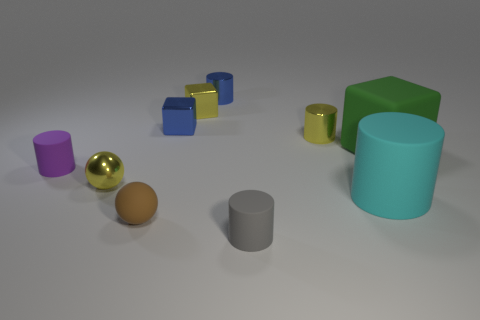Subtract all gray cylinders. How many cylinders are left? 4 Subtract all tiny blue cylinders. How many cylinders are left? 4 Subtract all red cylinders. Subtract all gray spheres. How many cylinders are left? 5 Subtract all balls. How many objects are left? 8 Subtract all large rubber cubes. Subtract all big objects. How many objects are left? 7 Add 5 tiny yellow shiny cylinders. How many tiny yellow shiny cylinders are left? 6 Add 8 shiny cylinders. How many shiny cylinders exist? 10 Subtract 0 green cylinders. How many objects are left? 10 